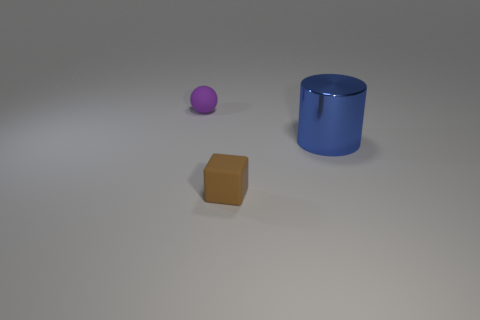Add 1 large metal things. How many objects exist? 4 Subtract all cylinders. How many objects are left? 2 Add 2 tiny yellow spheres. How many tiny yellow spheres exist? 2 Subtract 0 purple cylinders. How many objects are left? 3 Subtract 1 cylinders. How many cylinders are left? 0 Subtract all gray balls. Subtract all green cubes. How many balls are left? 1 Subtract all small brown matte blocks. Subtract all small brown rubber things. How many objects are left? 1 Add 1 brown cubes. How many brown cubes are left? 2 